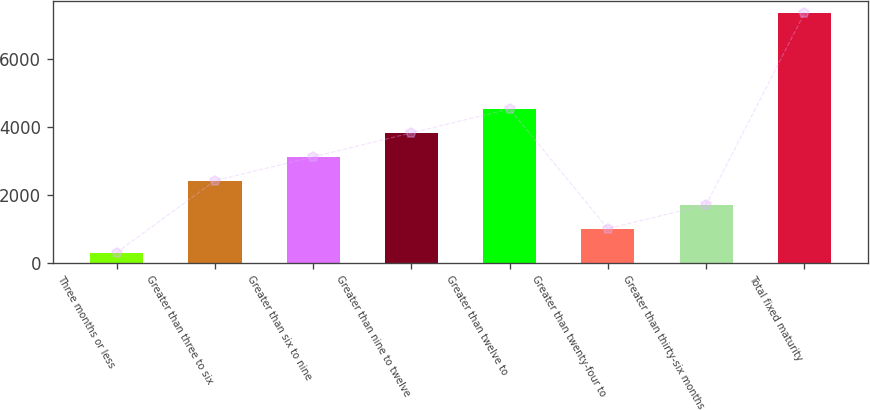Convert chart. <chart><loc_0><loc_0><loc_500><loc_500><bar_chart><fcel>Three months or less<fcel>Greater than three to six<fcel>Greater than six to nine<fcel>Greater than nine to twelve<fcel>Greater than twelve to<fcel>Greater than twenty-four to<fcel>Greater than thirty-six months<fcel>Total fixed maturity<nl><fcel>293.9<fcel>2408.42<fcel>3113.26<fcel>3818.1<fcel>4522.94<fcel>998.74<fcel>1703.58<fcel>7342.3<nl></chart> 